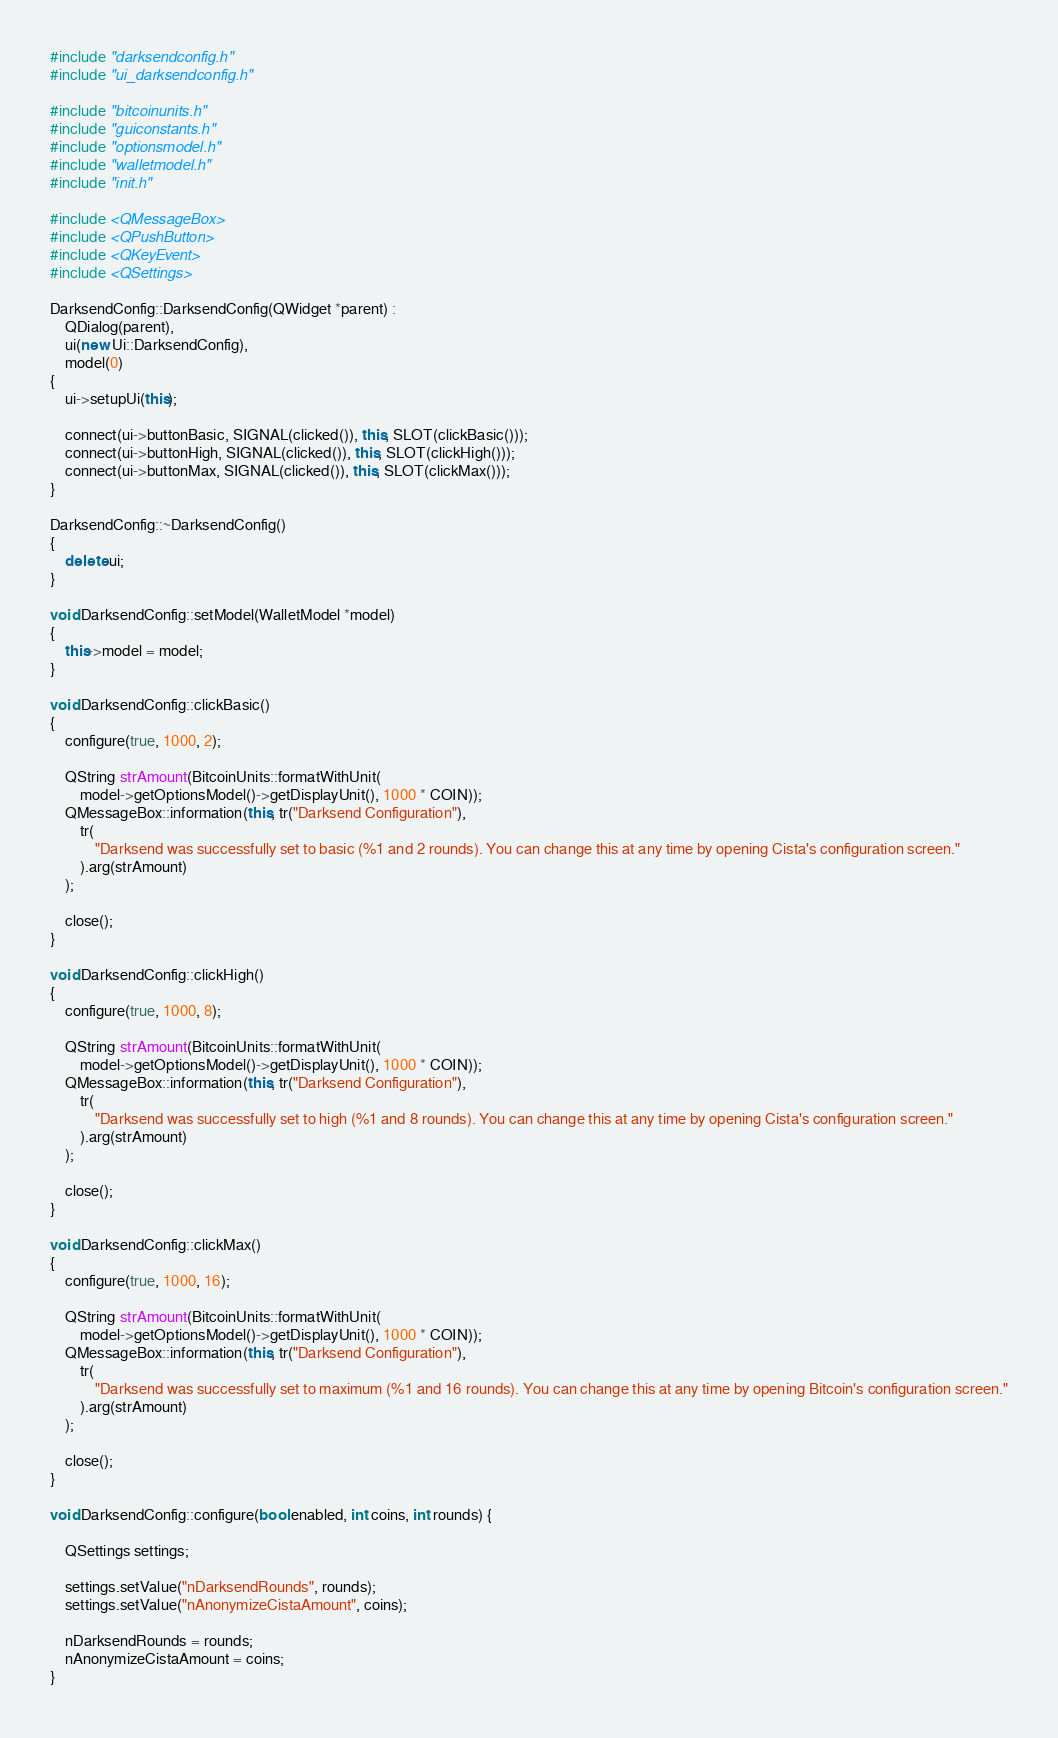<code> <loc_0><loc_0><loc_500><loc_500><_C++_>#include "darksendconfig.h"
#include "ui_darksendconfig.h"

#include "bitcoinunits.h"
#include "guiconstants.h"
#include "optionsmodel.h"
#include "walletmodel.h"
#include "init.h"

#include <QMessageBox>
#include <QPushButton>
#include <QKeyEvent>
#include <QSettings>

DarksendConfig::DarksendConfig(QWidget *parent) :
    QDialog(parent),
    ui(new Ui::DarksendConfig),
    model(0)
{
    ui->setupUi(this);

    connect(ui->buttonBasic, SIGNAL(clicked()), this, SLOT(clickBasic()));
    connect(ui->buttonHigh, SIGNAL(clicked()), this, SLOT(clickHigh()));
    connect(ui->buttonMax, SIGNAL(clicked()), this, SLOT(clickMax()));
}

DarksendConfig::~DarksendConfig()
{
    delete ui;
}

void DarksendConfig::setModel(WalletModel *model)
{
    this->model = model;
}

void DarksendConfig::clickBasic()
{
    configure(true, 1000, 2);

    QString strAmount(BitcoinUnits::formatWithUnit(
        model->getOptionsModel()->getDisplayUnit(), 1000 * COIN));
    QMessageBox::information(this, tr("Darksend Configuration"),
        tr(
            "Darksend was successfully set to basic (%1 and 2 rounds). You can change this at any time by opening Cista's configuration screen."
        ).arg(strAmount)
    );

    close();
}

void DarksendConfig::clickHigh()
{
    configure(true, 1000, 8);

    QString strAmount(BitcoinUnits::formatWithUnit(
        model->getOptionsModel()->getDisplayUnit(), 1000 * COIN));
    QMessageBox::information(this, tr("Darksend Configuration"),
        tr(
            "Darksend was successfully set to high (%1 and 8 rounds). You can change this at any time by opening Cista's configuration screen."
        ).arg(strAmount)
    );

    close();
}

void DarksendConfig::clickMax()
{
    configure(true, 1000, 16);

    QString strAmount(BitcoinUnits::formatWithUnit(
        model->getOptionsModel()->getDisplayUnit(), 1000 * COIN));
    QMessageBox::information(this, tr("Darksend Configuration"),
        tr(
            "Darksend was successfully set to maximum (%1 and 16 rounds). You can change this at any time by opening Bitcoin's configuration screen."
        ).arg(strAmount)
    );

    close();
}

void DarksendConfig::configure(bool enabled, int coins, int rounds) {

    QSettings settings;

    settings.setValue("nDarksendRounds", rounds);
    settings.setValue("nAnonymizeCistaAmount", coins);

    nDarksendRounds = rounds;
    nAnonymizeCistaAmount = coins;
}
</code> 